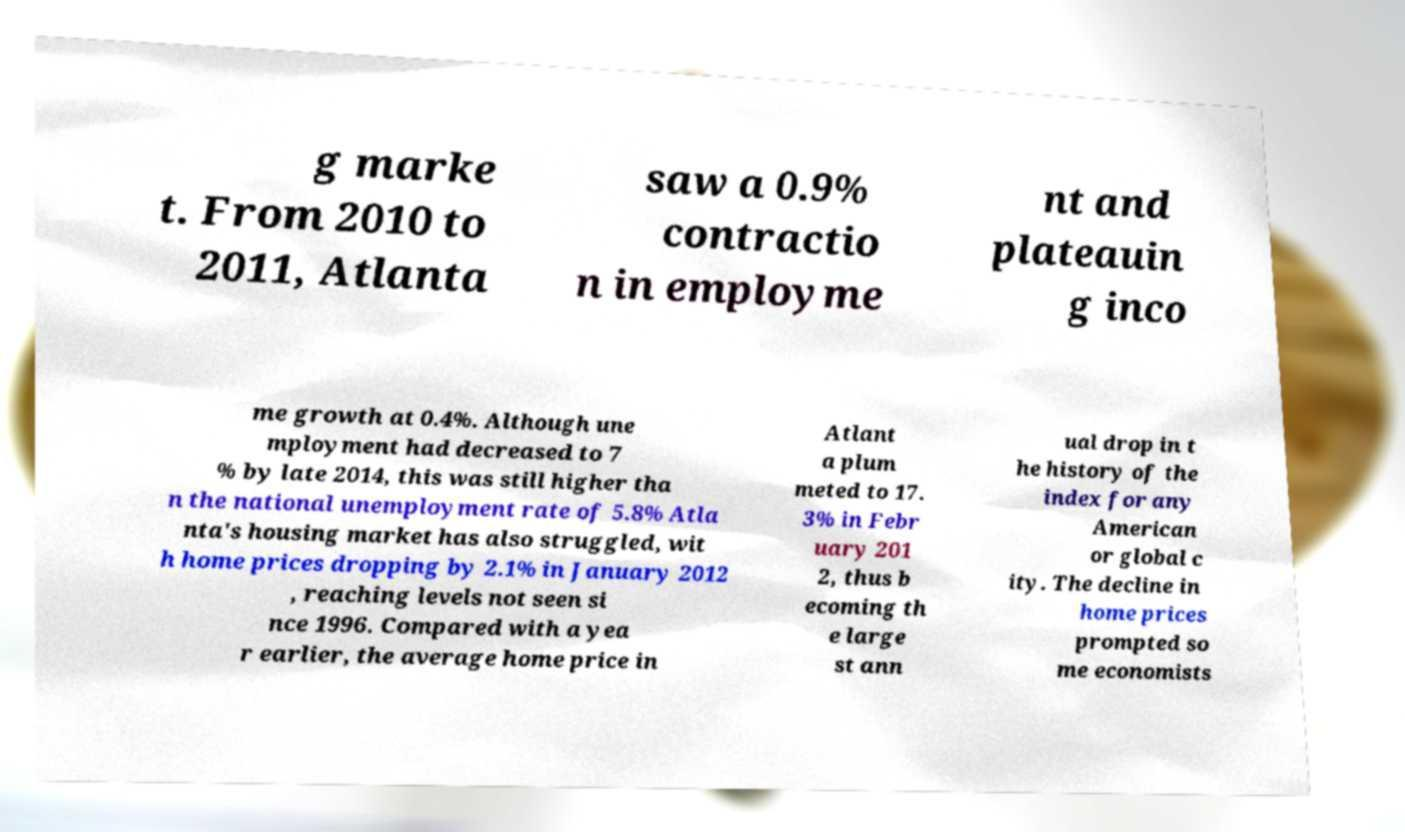I need the written content from this picture converted into text. Can you do that? g marke t. From 2010 to 2011, Atlanta saw a 0.9% contractio n in employme nt and plateauin g inco me growth at 0.4%. Although une mployment had decreased to 7 % by late 2014, this was still higher tha n the national unemployment rate of 5.8% Atla nta's housing market has also struggled, wit h home prices dropping by 2.1% in January 2012 , reaching levels not seen si nce 1996. Compared with a yea r earlier, the average home price in Atlant a plum meted to 17. 3% in Febr uary 201 2, thus b ecoming th e large st ann ual drop in t he history of the index for any American or global c ity. The decline in home prices prompted so me economists 